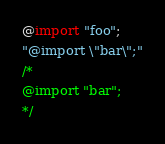<code> <loc_0><loc_0><loc_500><loc_500><_CSS_>@import "foo";
"@import \"bar\";"
/*
@import "bar";
*/
</code> 